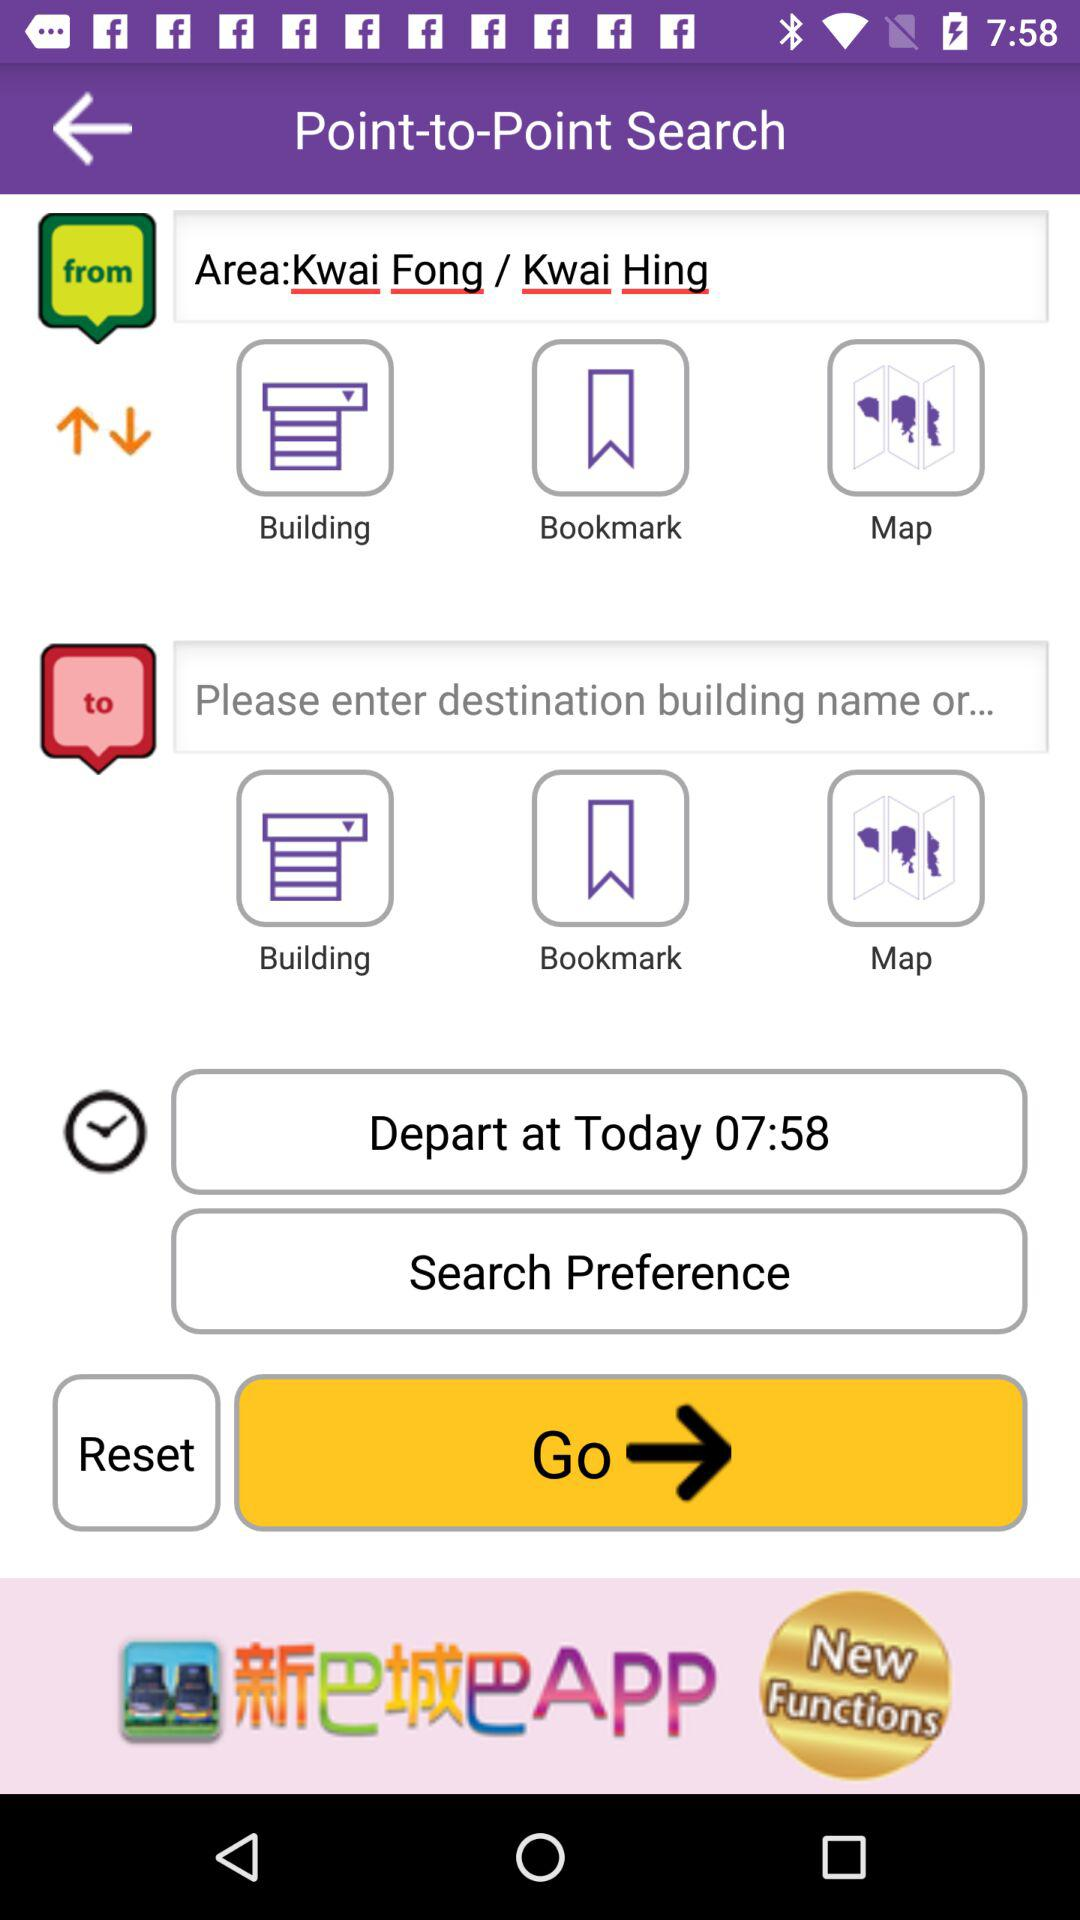What is the departure time? The departure time is 07:58. 